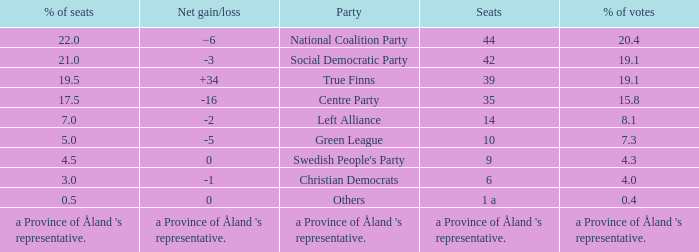Which party has a net gain/loss of -2? Left Alliance. 